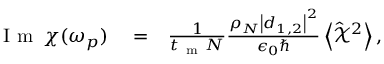Convert formula to latex. <formula><loc_0><loc_0><loc_500><loc_500>\begin{array} { r l r } { I m \, \chi ( \omega _ { p } ) } & = } & { \frac { 1 } { t _ { m } N } \frac { \rho _ { N } \left | \boldsymbol d _ { 1 , 2 } \right | ^ { 2 } } { \epsilon _ { 0 } } \left < \hat { \mathcal { X } } ^ { 2 } \right > , } \end{array}</formula> 